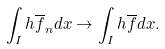Convert formula to latex. <formula><loc_0><loc_0><loc_500><loc_500>\int _ { I } h \overline { f } _ { n } d x \rightarrow \int _ { I } h \overline { f } d x .</formula> 